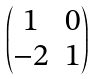<formula> <loc_0><loc_0><loc_500><loc_500>\begin{pmatrix} 1 & 0 \\ - 2 & 1 \end{pmatrix}</formula> 